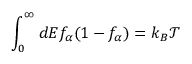<formula> <loc_0><loc_0><loc_500><loc_500>\int _ { 0 } ^ { \infty } d E f _ { \alpha } ( 1 - f _ { \alpha } ) = k _ { B } \mathcal { T }</formula> 